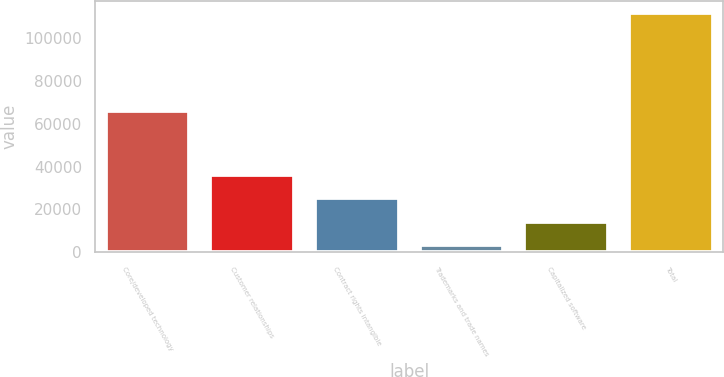Convert chart. <chart><loc_0><loc_0><loc_500><loc_500><bar_chart><fcel>Core/developed technology<fcel>Customer relationships<fcel>Contract rights intangible<fcel>Trademarks and trade names<fcel>Capitalized software<fcel>Total<nl><fcel>65916<fcel>36018.4<fcel>25205.6<fcel>3580<fcel>14392.8<fcel>111708<nl></chart> 